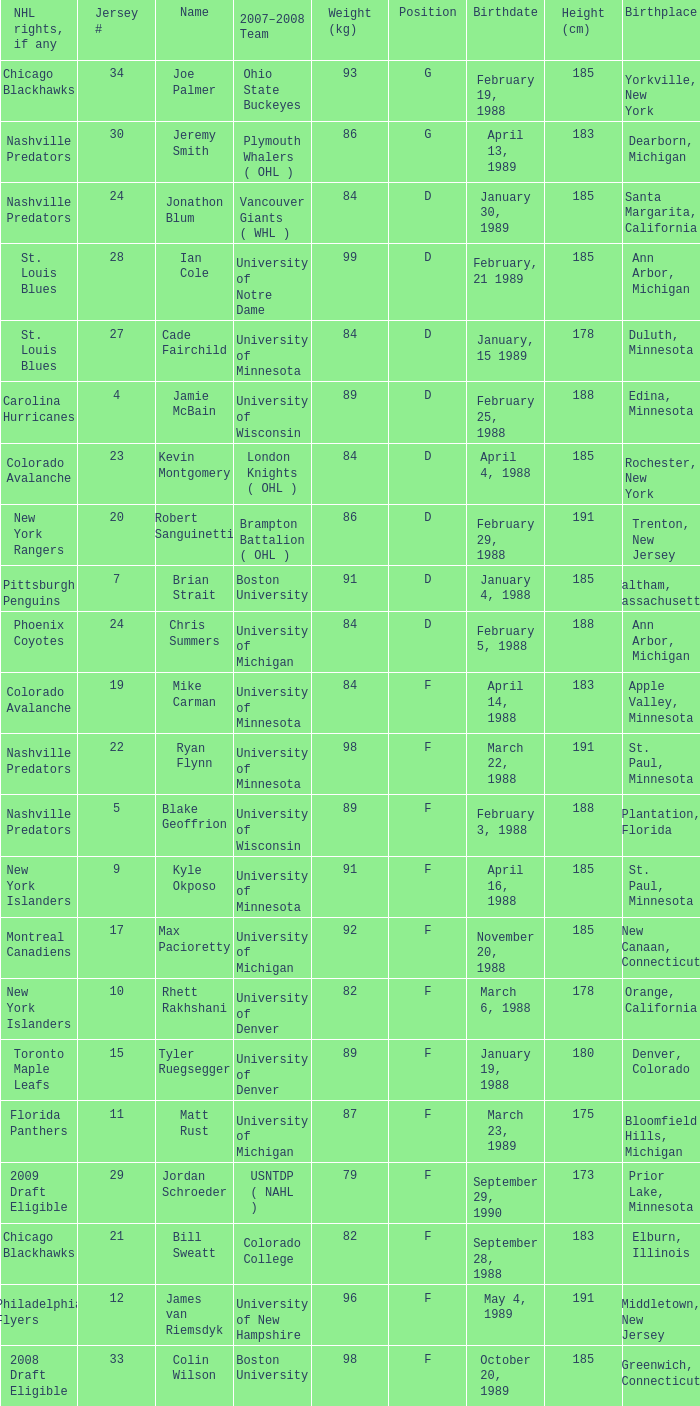Which Height (cm) has a Birthplace of bloomfield hills, michigan? 175.0. 